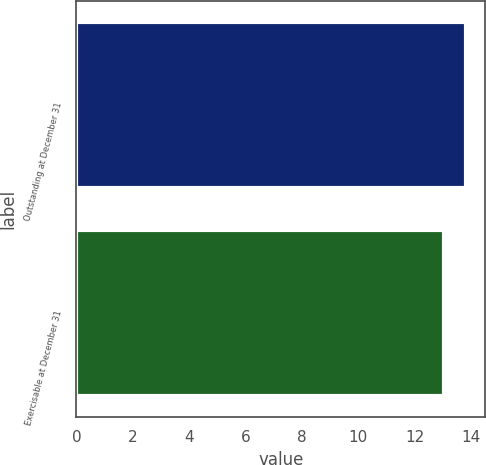<chart> <loc_0><loc_0><loc_500><loc_500><bar_chart><fcel>Outstanding at December 31<fcel>Exercisable at December 31<nl><fcel>13.81<fcel>13.05<nl></chart> 